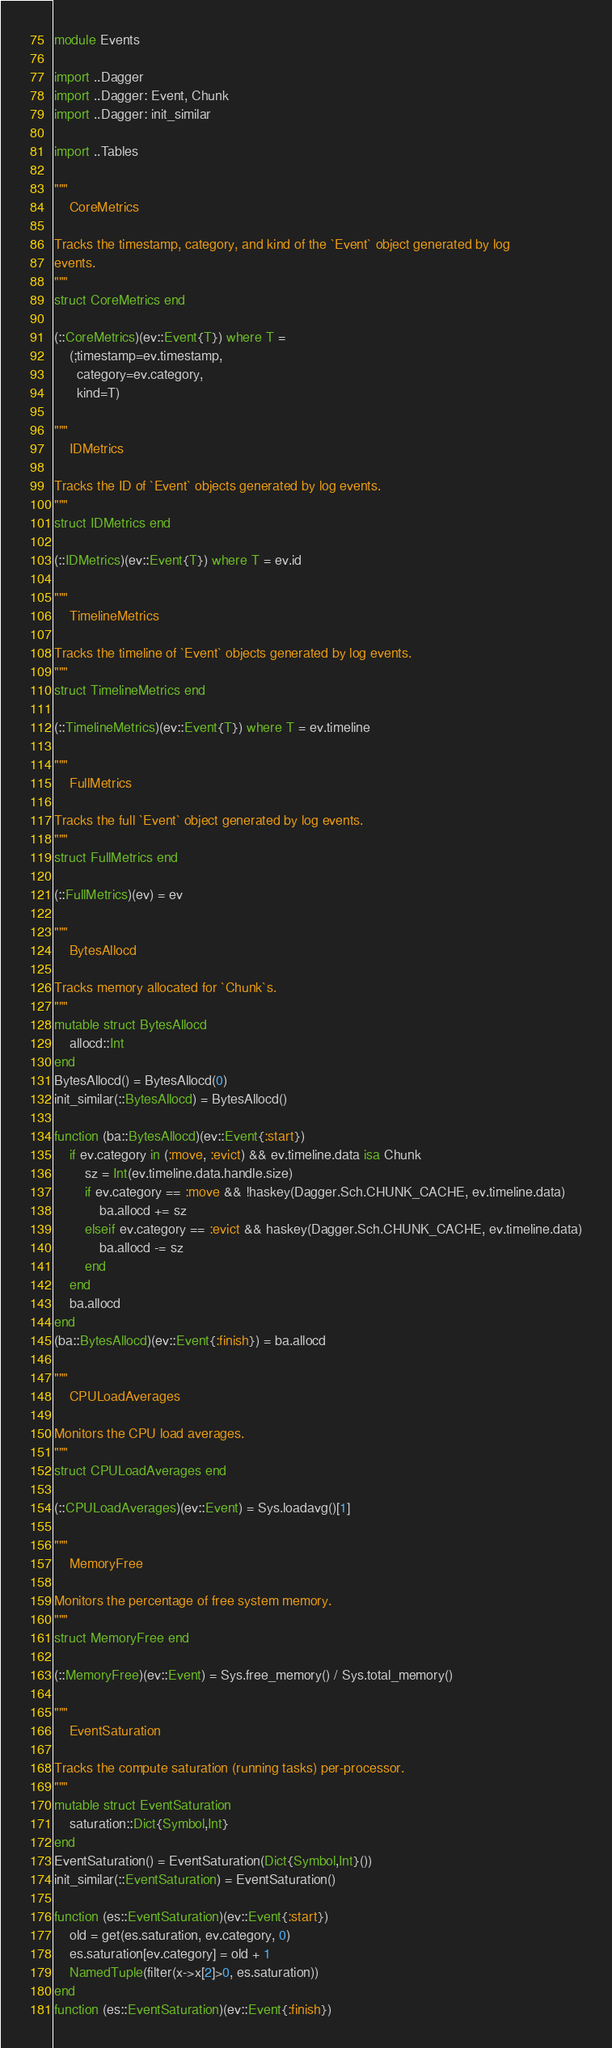Convert code to text. <code><loc_0><loc_0><loc_500><loc_500><_Julia_>module Events

import ..Dagger
import ..Dagger: Event, Chunk
import ..Dagger: init_similar

import ..Tables

"""
    CoreMetrics

Tracks the timestamp, category, and kind of the `Event` object generated by log
events.
"""
struct CoreMetrics end

(::CoreMetrics)(ev::Event{T}) where T =
    (;timestamp=ev.timestamp,
      category=ev.category,
      kind=T)

"""
    IDMetrics

Tracks the ID of `Event` objects generated by log events.
"""
struct IDMetrics end

(::IDMetrics)(ev::Event{T}) where T = ev.id

"""
    TimelineMetrics

Tracks the timeline of `Event` objects generated by log events.
"""
struct TimelineMetrics end

(::TimelineMetrics)(ev::Event{T}) where T = ev.timeline

"""
    FullMetrics

Tracks the full `Event` object generated by log events.
"""
struct FullMetrics end

(::FullMetrics)(ev) = ev

"""
    BytesAllocd

Tracks memory allocated for `Chunk`s.
"""
mutable struct BytesAllocd
    allocd::Int
end
BytesAllocd() = BytesAllocd(0)
init_similar(::BytesAllocd) = BytesAllocd()

function (ba::BytesAllocd)(ev::Event{:start})
    if ev.category in (:move, :evict) && ev.timeline.data isa Chunk
        sz = Int(ev.timeline.data.handle.size)
        if ev.category == :move && !haskey(Dagger.Sch.CHUNK_CACHE, ev.timeline.data)
            ba.allocd += sz
        elseif ev.category == :evict && haskey(Dagger.Sch.CHUNK_CACHE, ev.timeline.data)
            ba.allocd -= sz
        end
    end
    ba.allocd
end
(ba::BytesAllocd)(ev::Event{:finish}) = ba.allocd

"""
    CPULoadAverages

Monitors the CPU load averages.
"""
struct CPULoadAverages end

(::CPULoadAverages)(ev::Event) = Sys.loadavg()[1]

"""
    MemoryFree

Monitors the percentage of free system memory.
"""
struct MemoryFree end

(::MemoryFree)(ev::Event) = Sys.free_memory() / Sys.total_memory()

"""
    EventSaturation

Tracks the compute saturation (running tasks) per-processor.
"""
mutable struct EventSaturation
    saturation::Dict{Symbol,Int}
end
EventSaturation() = EventSaturation(Dict{Symbol,Int}())
init_similar(::EventSaturation) = EventSaturation()

function (es::EventSaturation)(ev::Event{:start})
    old = get(es.saturation, ev.category, 0)
    es.saturation[ev.category] = old + 1
    NamedTuple(filter(x->x[2]>0, es.saturation))
end
function (es::EventSaturation)(ev::Event{:finish})</code> 